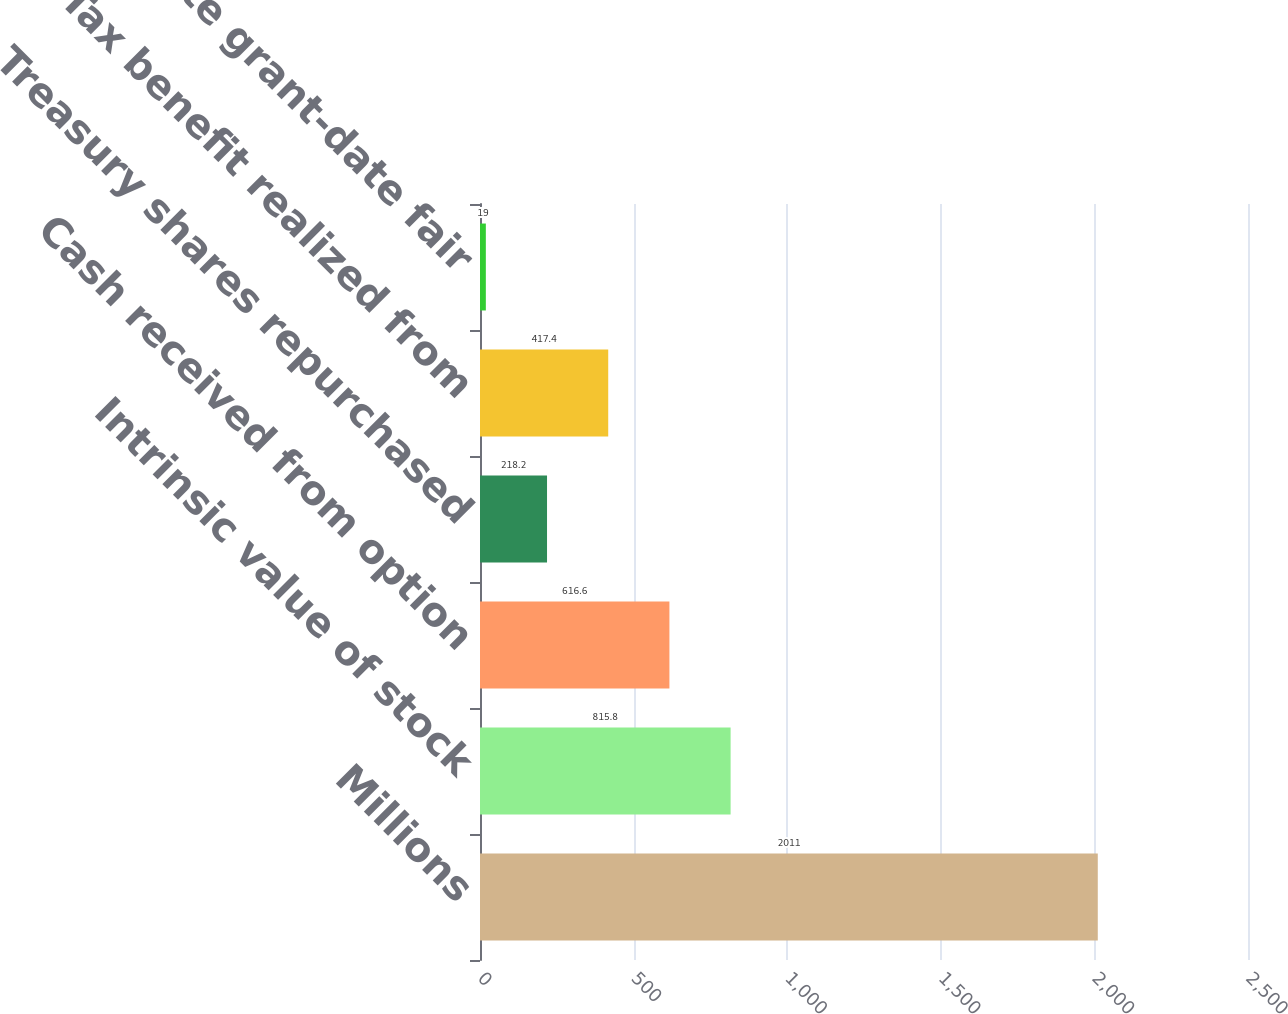Convert chart. <chart><loc_0><loc_0><loc_500><loc_500><bar_chart><fcel>Millions<fcel>Intrinsic value of stock<fcel>Cash received from option<fcel>Treasury shares repurchased<fcel>Tax benefit realized from<fcel>Aggregate grant-date fair<nl><fcel>2011<fcel>815.8<fcel>616.6<fcel>218.2<fcel>417.4<fcel>19<nl></chart> 